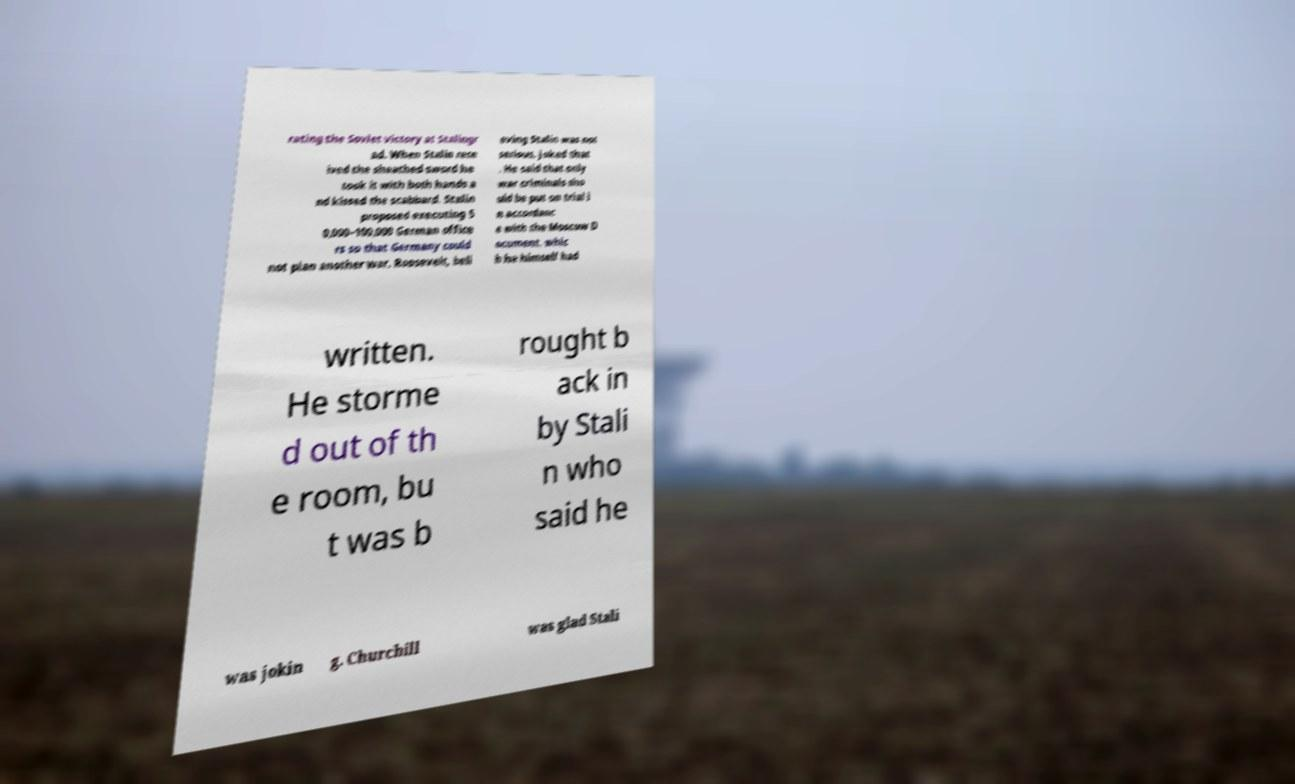I need the written content from this picture converted into text. Can you do that? rating the Soviet victory at Stalingr ad. When Stalin rece ived the sheathed sword he took it with both hands a nd kissed the scabbard. Stalin proposed executing 5 0,000–100,000 German office rs so that Germany could not plan another war. Roosevelt, beli eving Stalin was not serious, joked that . He said that only war criminals sho uld be put on trial i n accordanc e with the Moscow D ocument, whic h he himself had written. He storme d out of th e room, bu t was b rought b ack in by Stali n who said he was jokin g. Churchill was glad Stali 